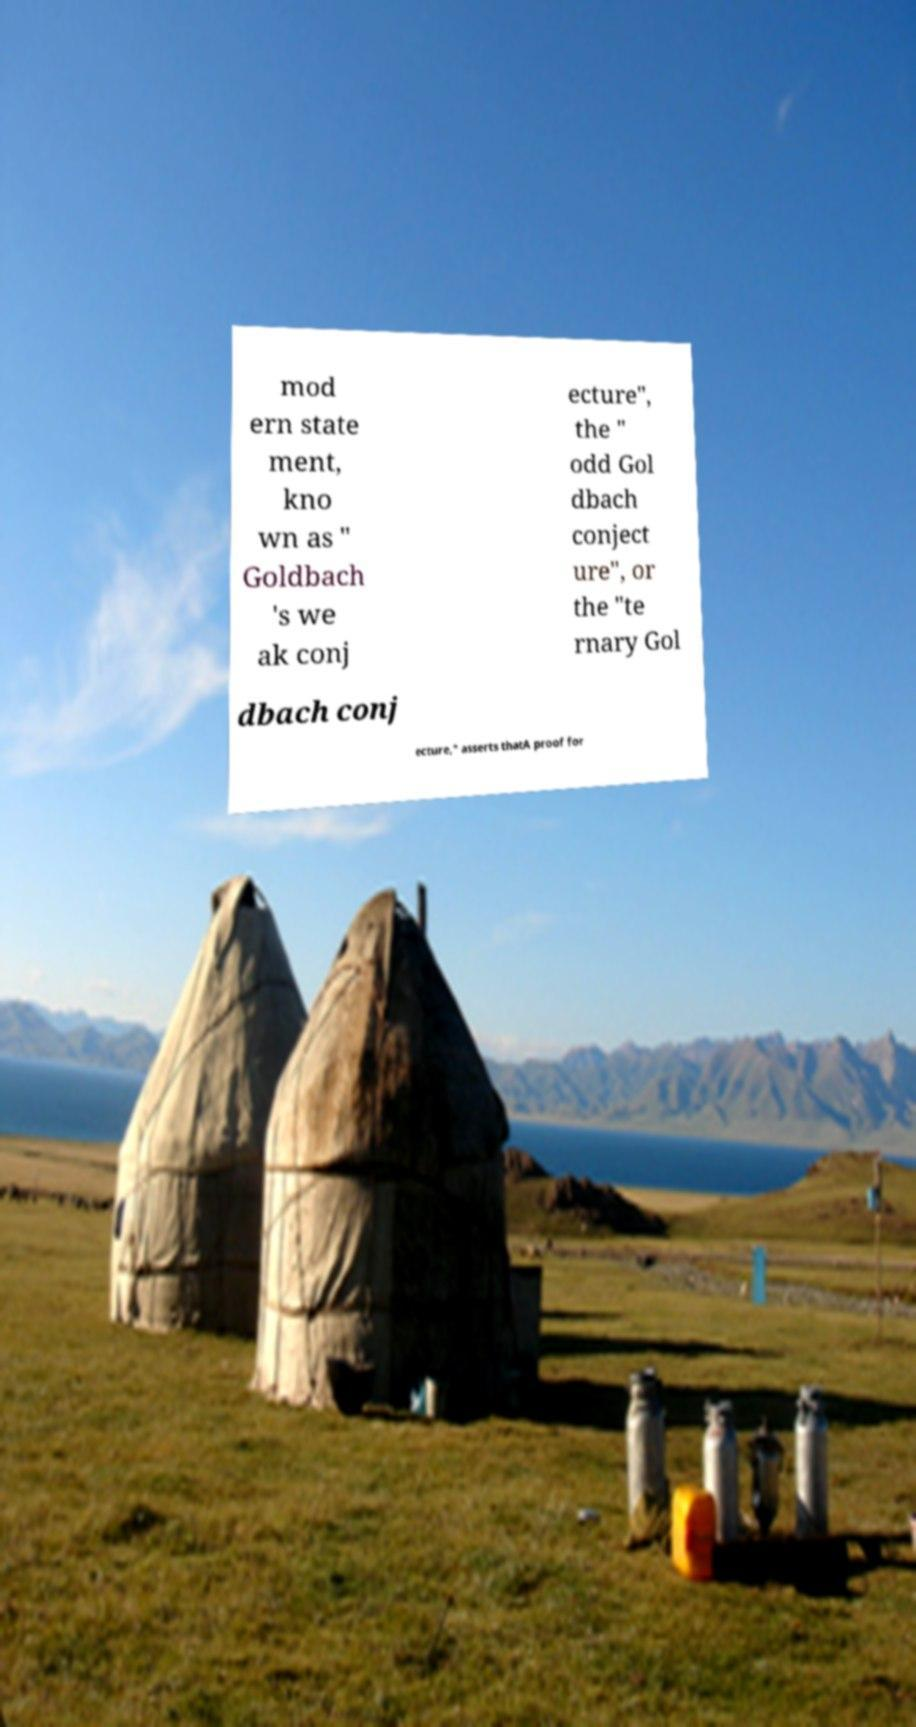I need the written content from this picture converted into text. Can you do that? mod ern state ment, kno wn as " Goldbach 's we ak conj ecture", the " odd Gol dbach conject ure", or the "te rnary Gol dbach conj ecture," asserts thatA proof for 